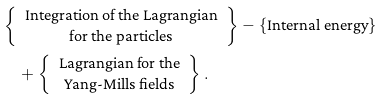<formula> <loc_0><loc_0><loc_500><loc_500>& \left \{ \begin{array} { c c } \text {Integration of the Lagrangian} \\ \text {for the particles} \end{array} \right \} - \{ \text {Internal energy} \} \\ & \quad + \left \{ \begin{array} { c c } \text {Lagrangian for the} \\ \text {Yang-Mills fields} \end{array} \right \} .</formula> 